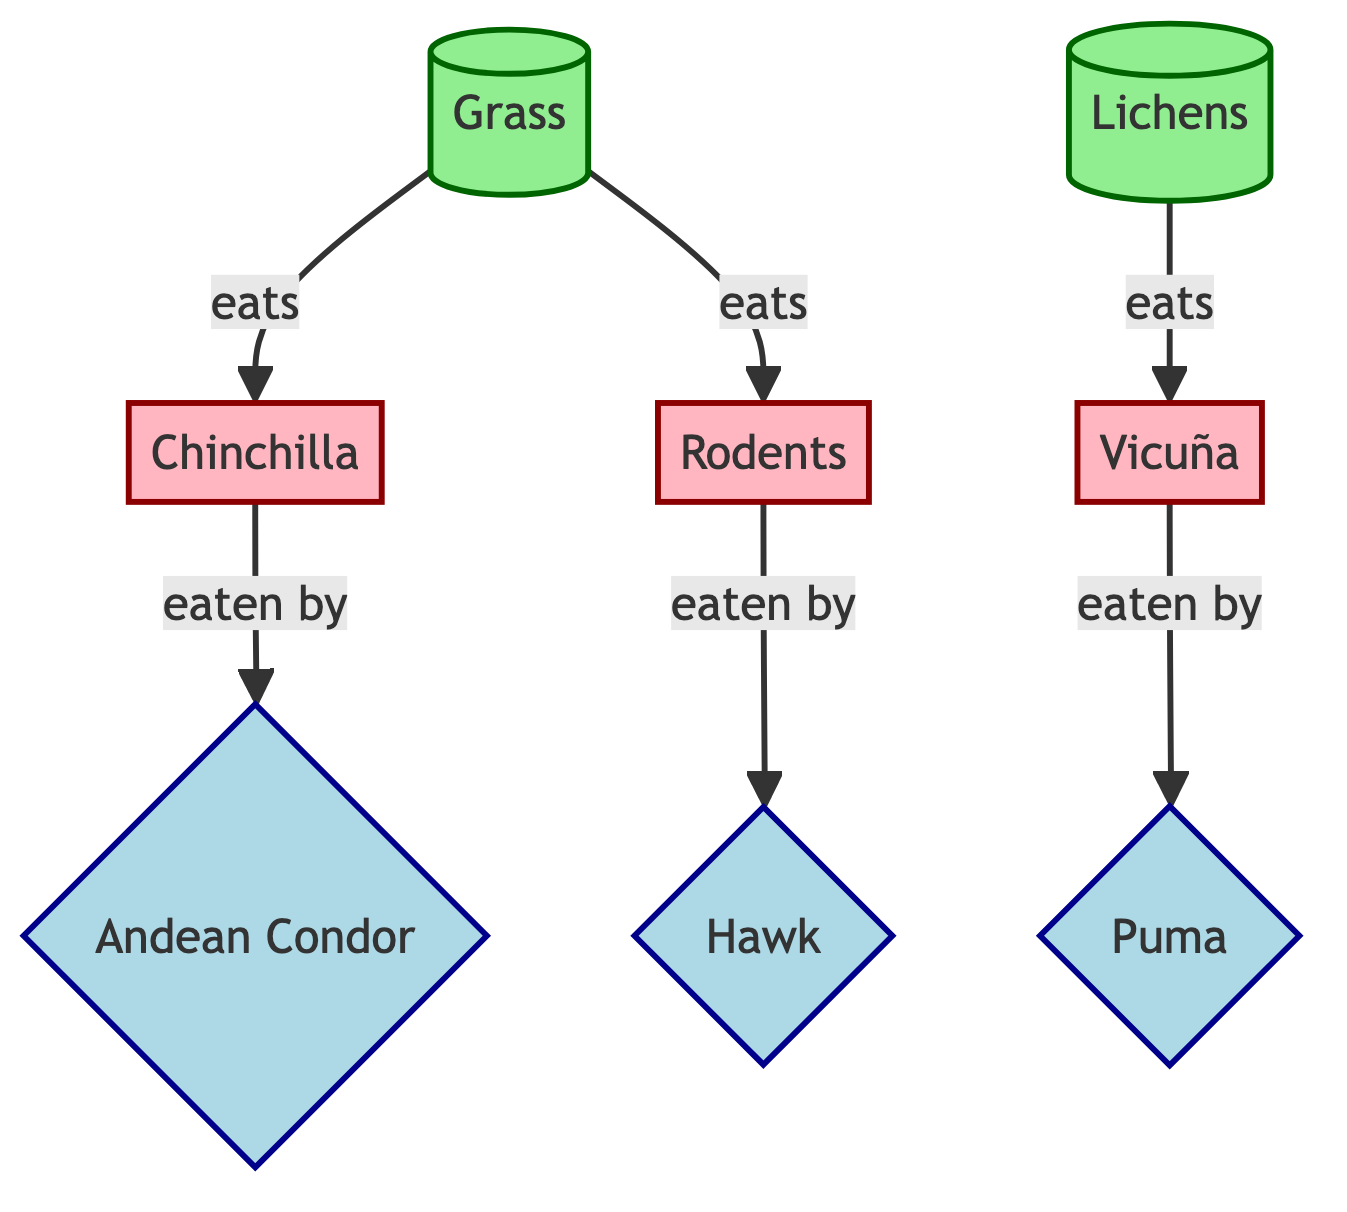What are the producers in the food chain? The producers in the food chain are the organisms that create energy for the system; in the diagram, these are Grass and Lichens, indicated by their classification.
Answer: Grass, Lichens How many prey species are represented in the diagram? By counting the nodes that are labeled as prey, we see three nodes: Chinchilla, Vicuña, and Rodents.
Answer: 3 Which predator eats Vicuñas? To answer this, we can trace the flow from the Vicuña node; the arrow indicates that the Puma is the predator that consumes them.
Answer: Puma What type of relationship exists between Grass and Chinchillas? The relationship depicted in the diagram shows that Grass serves as food for Chinchillas, which is indicated by an arrow pointing from Grass to Chinchilla.
Answer: eats Which predator is shown to eat Rodents? By following the connections in the diagram, Rodents are indicated to be eaten by Hawks, as shown by the arrow directed towards the Hawk node.
Answer: Hawk What is the total number of connections (edges) in the food chain? To find the total number of connections, we can count each directed arrow in the diagram; there are a total of six arrows, representing the flow between producers, prey, and predators.
Answer: 6 Are Lichens a producer or a predator? Lichens are categorized as a producer in the diagram, as indicated by its classification and the fact that it produces energy for other organisms.
Answer: producer What is the relationship between Chinchillas and Andean Condors? The diagram shows that Chinchillas are consumed by Andean Condors, indicated through the directional flow from Chinchilla to Andean Condor.
Answer: eaten by What type of animal is the Puma classified as in the food chain? The Puma is classified as a predator in the food chain, which is defined by its role in consuming prey, as shown in the diagram.
Answer: predator 